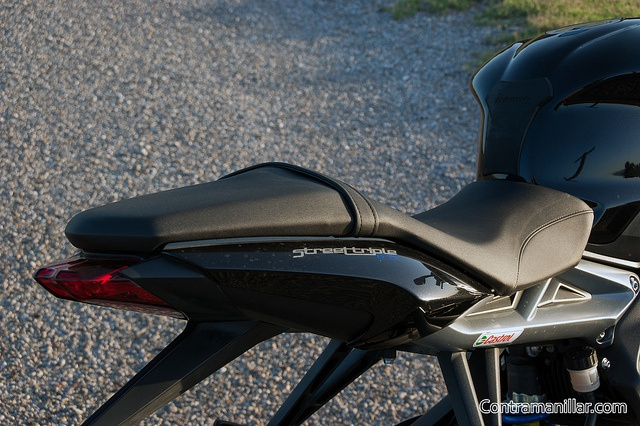Describe the objects in this image and their specific colors. I can see a motorcycle in gray, black, darkblue, and darkgray tones in this image. 